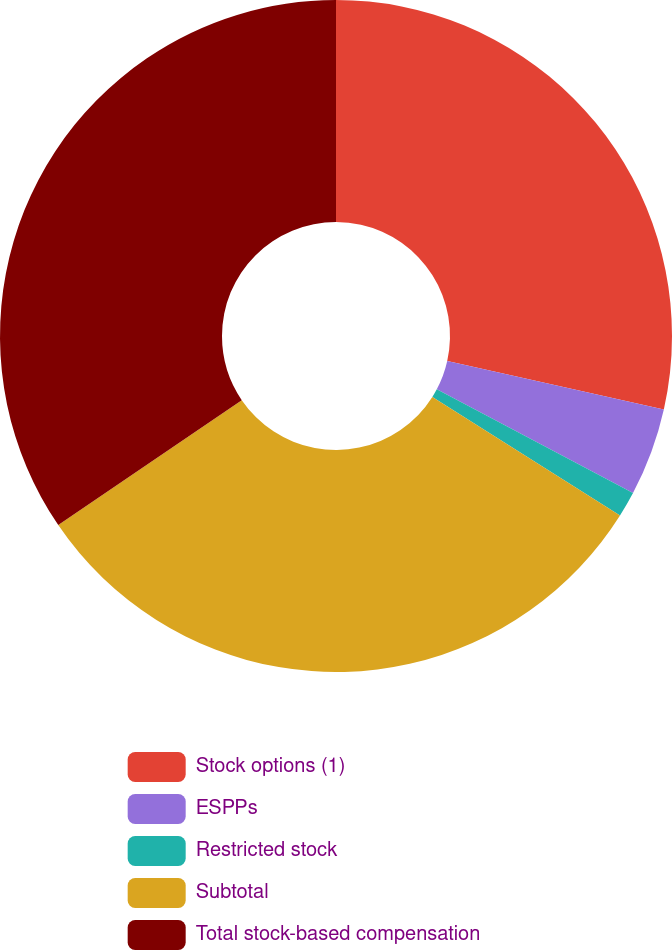<chart> <loc_0><loc_0><loc_500><loc_500><pie_chart><fcel>Stock options (1)<fcel>ESPPs<fcel>Restricted stock<fcel>Subtotal<fcel>Total stock-based compensation<nl><fcel>28.52%<fcel>4.23%<fcel>1.23%<fcel>31.52%<fcel>34.52%<nl></chart> 